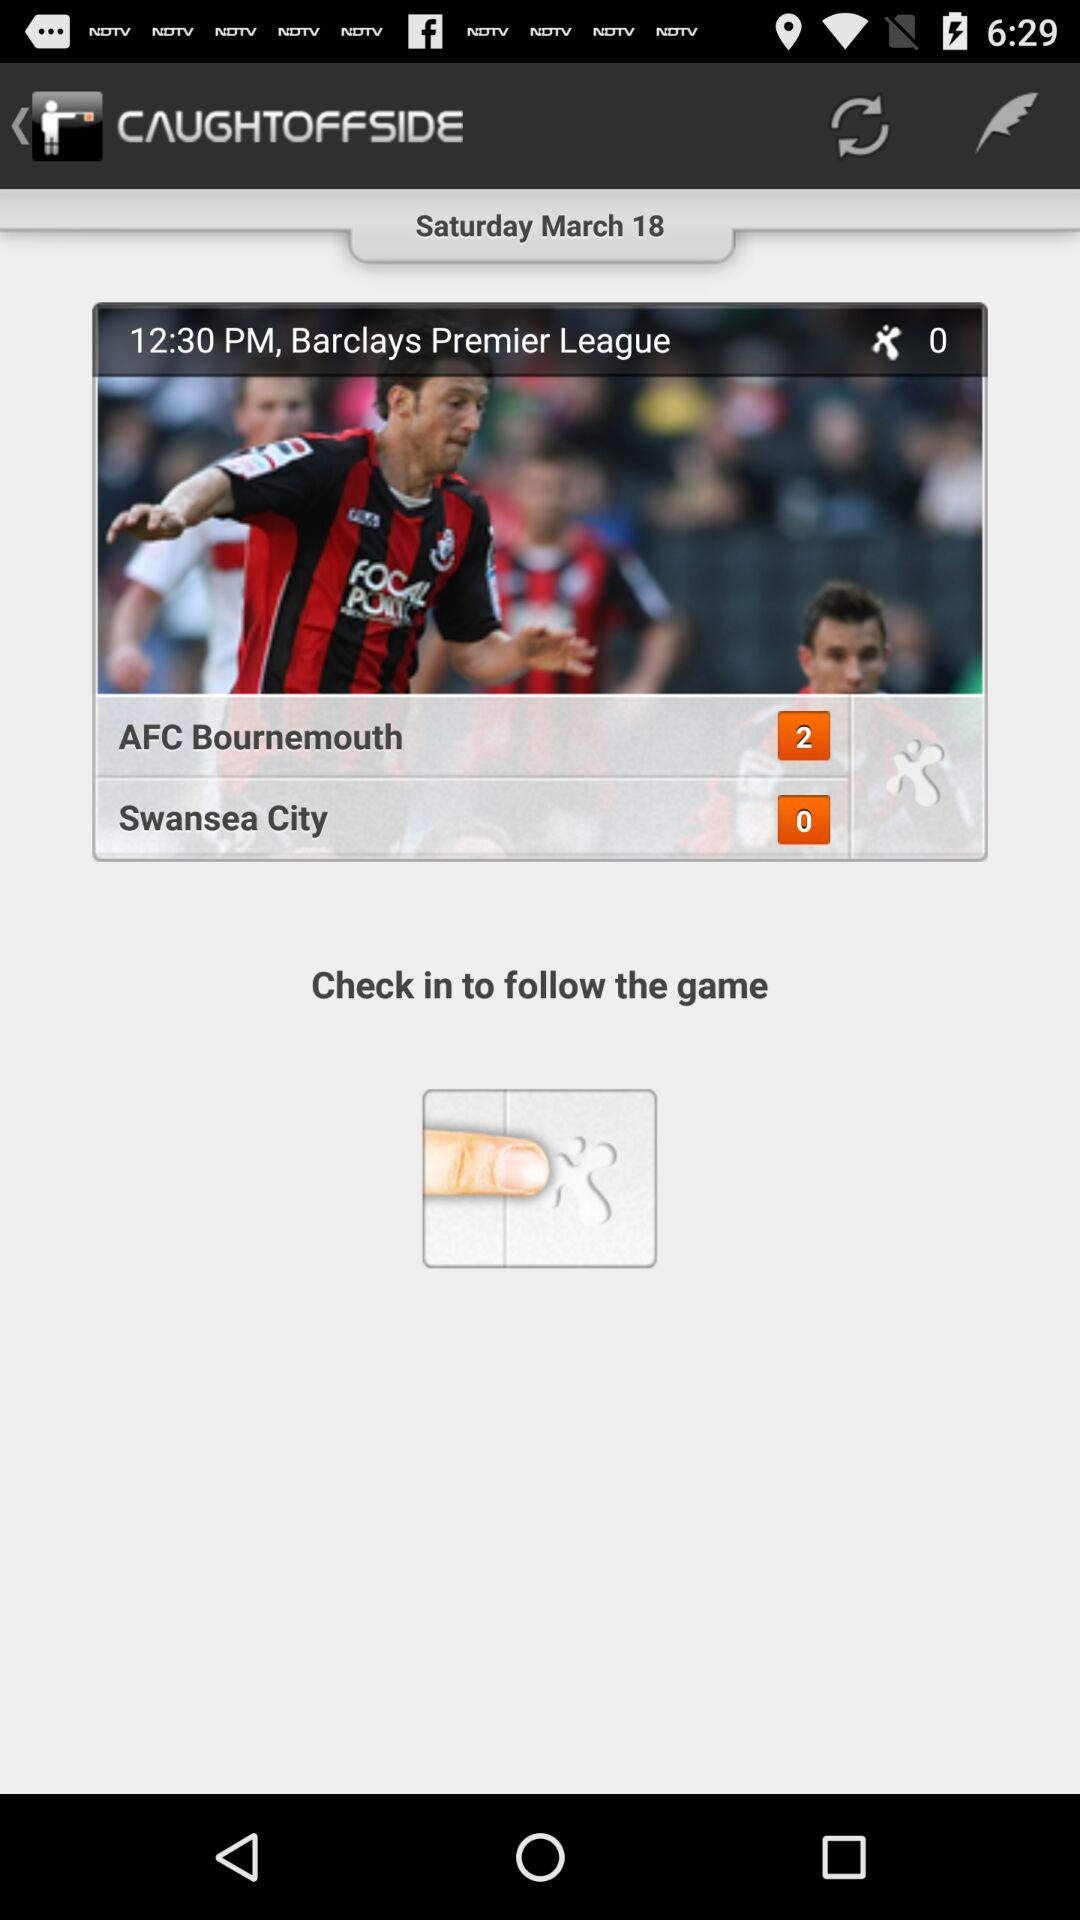Which team has a score of two points? The team "AFC Bournemouth" has a score of two points. 